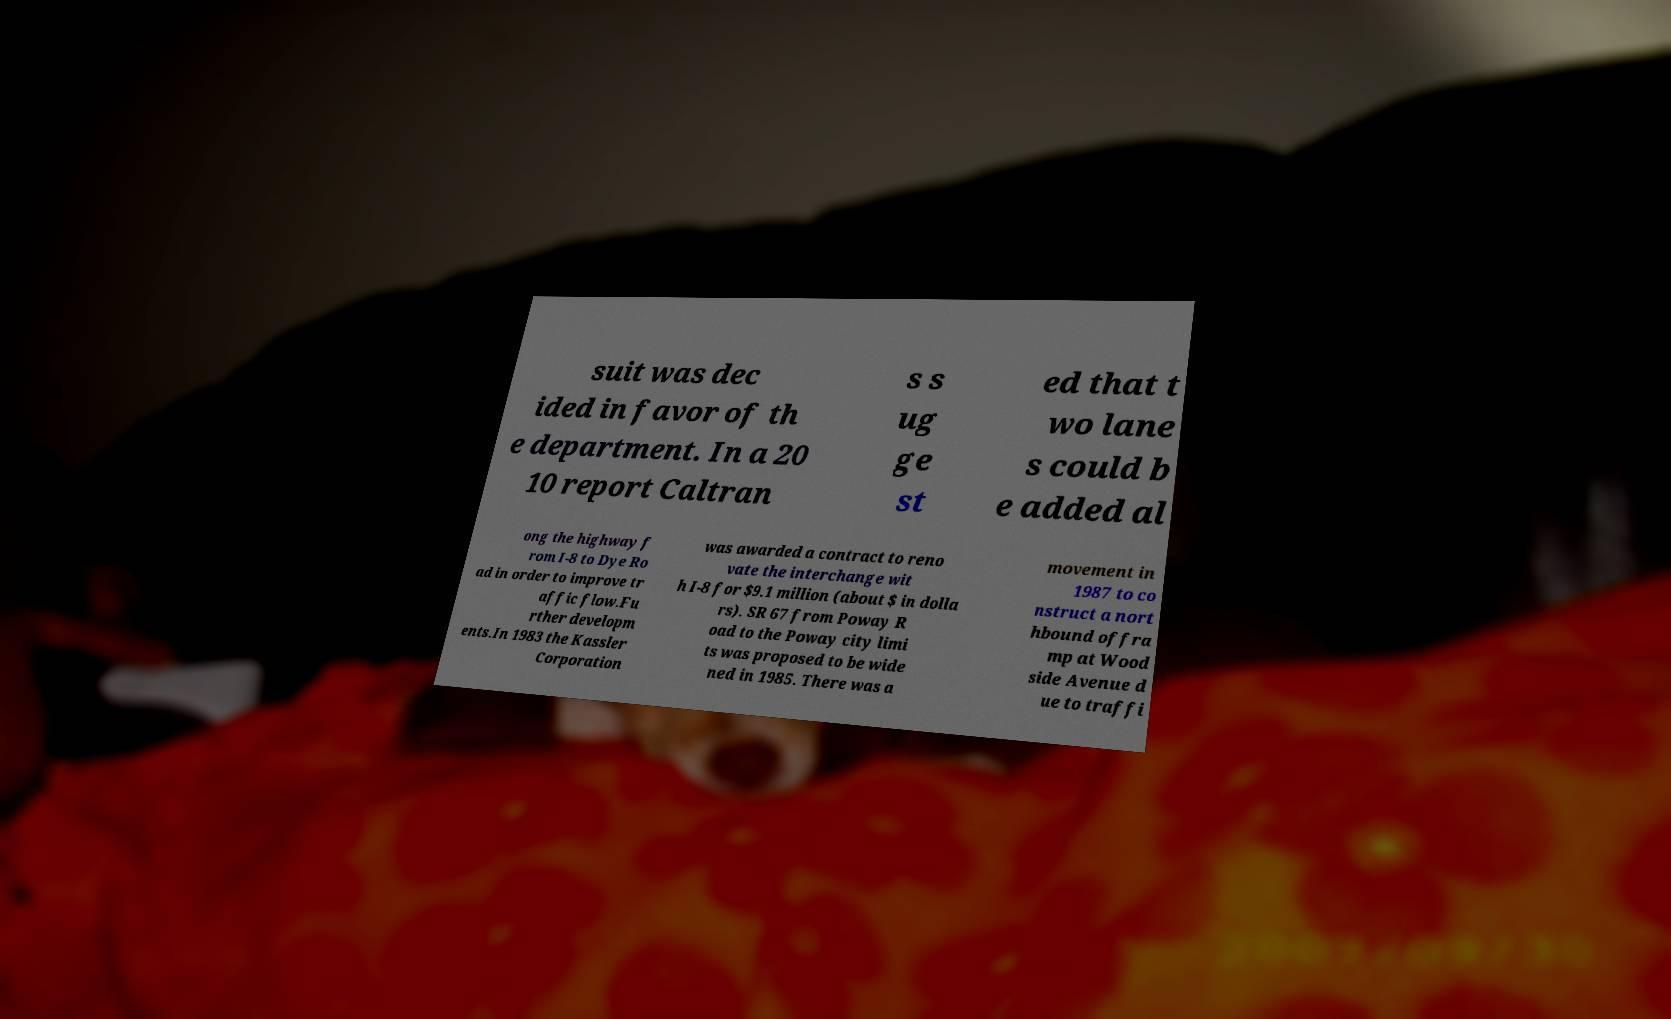Could you assist in decoding the text presented in this image and type it out clearly? suit was dec ided in favor of th e department. In a 20 10 report Caltran s s ug ge st ed that t wo lane s could b e added al ong the highway f rom I-8 to Dye Ro ad in order to improve tr affic flow.Fu rther developm ents.In 1983 the Kassler Corporation was awarded a contract to reno vate the interchange wit h I-8 for $9.1 million (about $ in dolla rs). SR 67 from Poway R oad to the Poway city limi ts was proposed to be wide ned in 1985. There was a movement in 1987 to co nstruct a nort hbound offra mp at Wood side Avenue d ue to traffi 